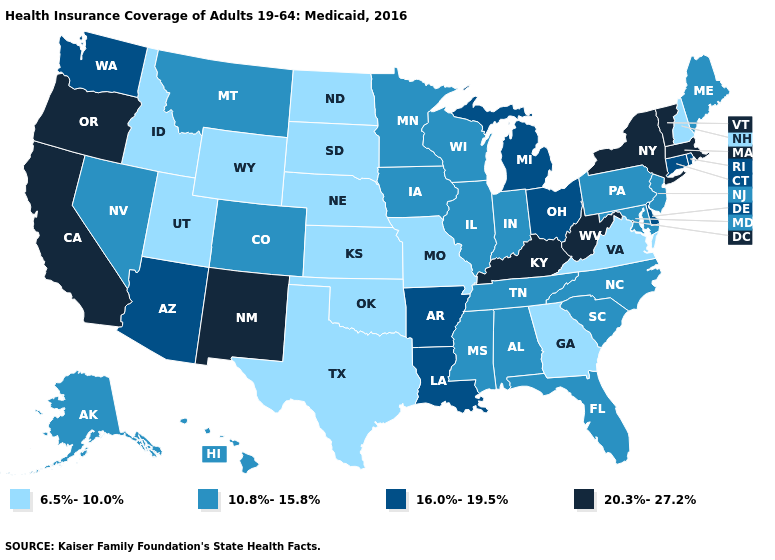What is the highest value in the MidWest ?
Give a very brief answer. 16.0%-19.5%. Does Oregon have the highest value in the USA?
Give a very brief answer. Yes. Is the legend a continuous bar?
Give a very brief answer. No. How many symbols are there in the legend?
Be succinct. 4. Among the states that border Wyoming , does Utah have the highest value?
Give a very brief answer. No. What is the value of Delaware?
Concise answer only. 16.0%-19.5%. Does the map have missing data?
Short answer required. No. Name the states that have a value in the range 16.0%-19.5%?
Give a very brief answer. Arizona, Arkansas, Connecticut, Delaware, Louisiana, Michigan, Ohio, Rhode Island, Washington. What is the value of Montana?
Quick response, please. 10.8%-15.8%. Among the states that border Rhode Island , which have the lowest value?
Keep it brief. Connecticut. Name the states that have a value in the range 10.8%-15.8%?
Answer briefly. Alabama, Alaska, Colorado, Florida, Hawaii, Illinois, Indiana, Iowa, Maine, Maryland, Minnesota, Mississippi, Montana, Nevada, New Jersey, North Carolina, Pennsylvania, South Carolina, Tennessee, Wisconsin. Name the states that have a value in the range 6.5%-10.0%?
Keep it brief. Georgia, Idaho, Kansas, Missouri, Nebraska, New Hampshire, North Dakota, Oklahoma, South Dakota, Texas, Utah, Virginia, Wyoming. Name the states that have a value in the range 16.0%-19.5%?
Quick response, please. Arizona, Arkansas, Connecticut, Delaware, Louisiana, Michigan, Ohio, Rhode Island, Washington. Does Kansas have the lowest value in the MidWest?
Keep it brief. Yes. What is the highest value in the Northeast ?
Give a very brief answer. 20.3%-27.2%. 